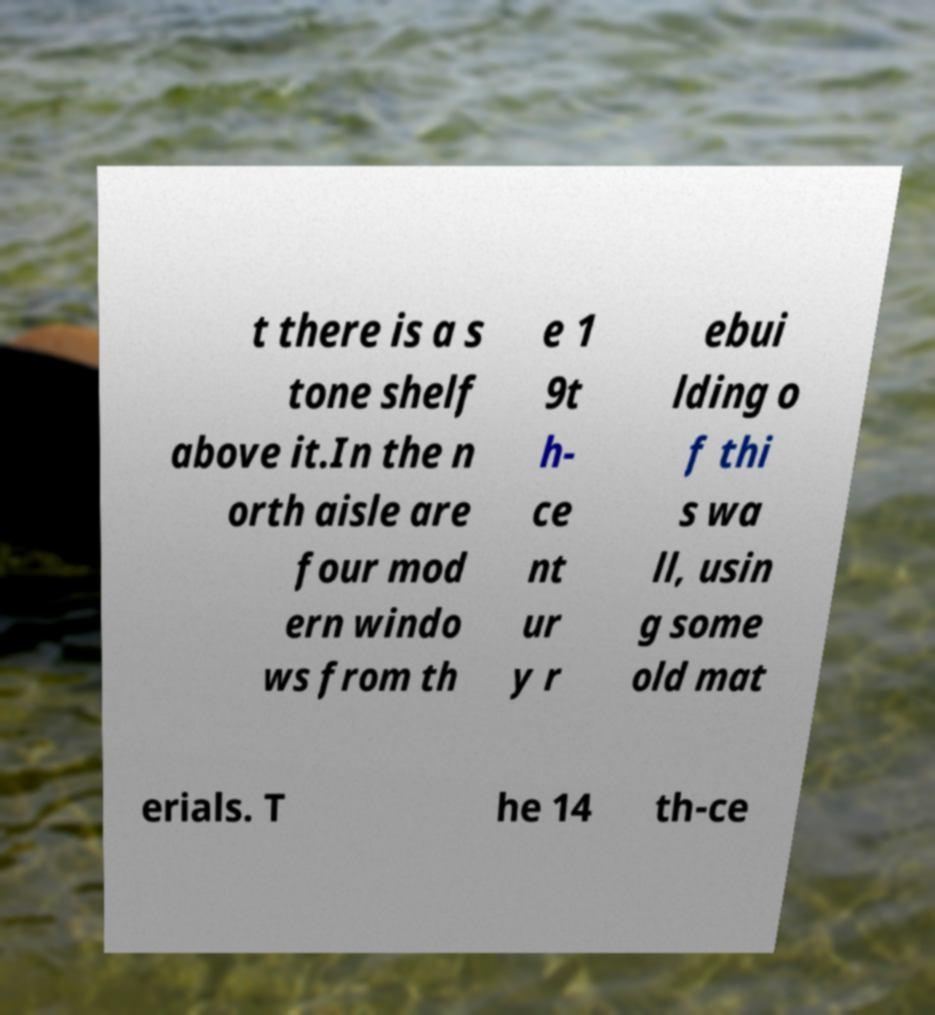There's text embedded in this image that I need extracted. Can you transcribe it verbatim? t there is a s tone shelf above it.In the n orth aisle are four mod ern windo ws from th e 1 9t h- ce nt ur y r ebui lding o f thi s wa ll, usin g some old mat erials. T he 14 th-ce 